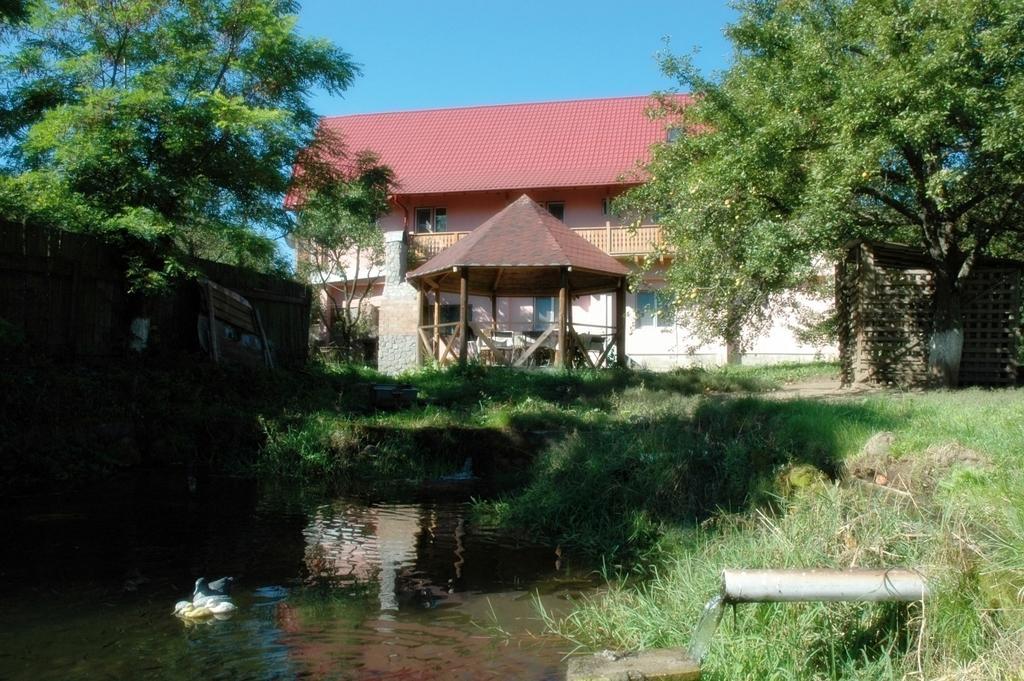Could you give a brief overview of what you see in this image? In the foreground of this image, there is water and ducks on it. On the right, there is grass, water coming through a pipe. In the background, there is a wooden shed, trees, building, tent, chairs, a wooden wall and the sky. 